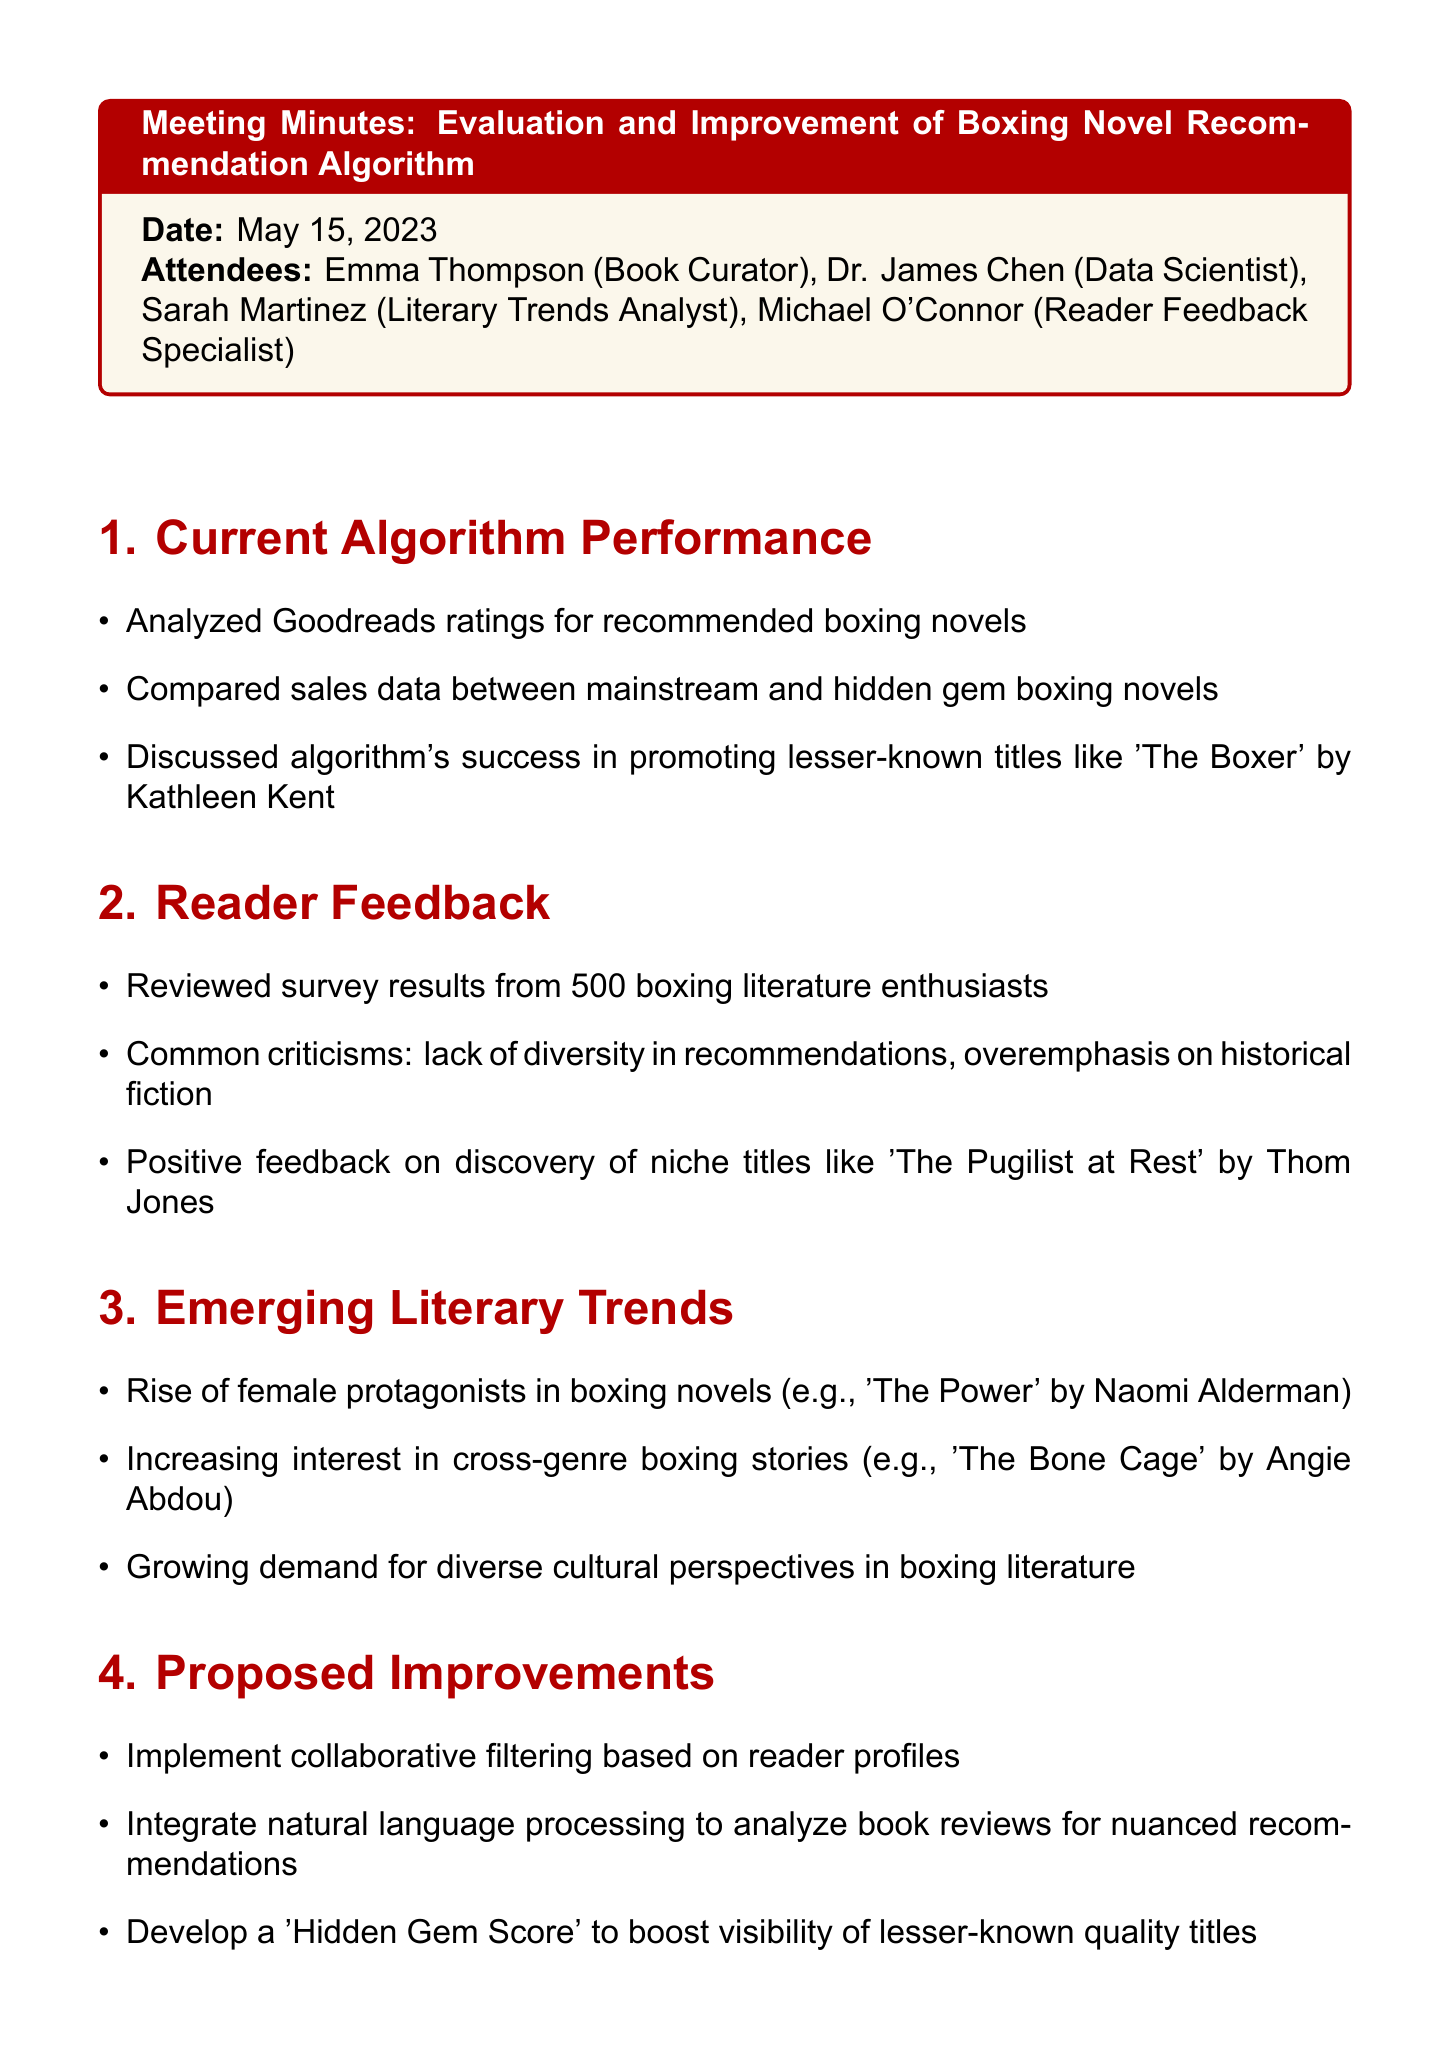What is the meeting date? The meeting date is specified at the beginning of the document.
Answer: May 15, 2023 Who is the Literary Trends Analyst? The attendees section lists all participants and their roles.
Answer: Sarah Martinez What was a common criticism noted in the reader feedback? The document highlights several points from the reader feedback, including criticisms.
Answer: Lack of diversity in recommendations Which title was mentioned as a hidden gem boxing novel? The current algorithm performance section discusses specific titles, including lesser-known ones.
Answer: The Boxer by Kathleen Kent What is one proposed improvement for the algorithm? The proposed improvements section lists multiple suggestions for enhancing the algorithm.
Answer: Implement collaborative filtering based on reader profiles What is Dr. Chen tasked with completing by June 15? The action items specify individual responsibilities and their deadlines.
Answer: Prototype of improved algorithm When will Sarah compile her report? The action items state the due date for Sarah's report on boxing literature trends.
Answer: May 30 What type of stories is increasing in interest according to emerging literary trends? The emerging literary trends section identifies changes in reader interest.
Answer: Cross-genre boxing stories What is the purpose of the 'Hidden Gem Score'? The proposed improvements section notes a specific purpose for this score.
Answer: Boost visibility of lesser-known quality titles 